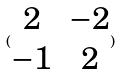<formula> <loc_0><loc_0><loc_500><loc_500>( \begin{matrix} 2 & - 2 \\ - 1 & 2 \end{matrix} )</formula> 